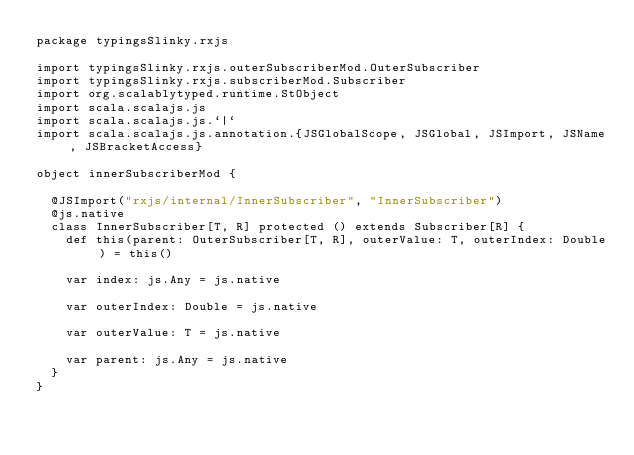Convert code to text. <code><loc_0><loc_0><loc_500><loc_500><_Scala_>package typingsSlinky.rxjs

import typingsSlinky.rxjs.outerSubscriberMod.OuterSubscriber
import typingsSlinky.rxjs.subscriberMod.Subscriber
import org.scalablytyped.runtime.StObject
import scala.scalajs.js
import scala.scalajs.js.`|`
import scala.scalajs.js.annotation.{JSGlobalScope, JSGlobal, JSImport, JSName, JSBracketAccess}

object innerSubscriberMod {
  
  @JSImport("rxjs/internal/InnerSubscriber", "InnerSubscriber")
  @js.native
  class InnerSubscriber[T, R] protected () extends Subscriber[R] {
    def this(parent: OuterSubscriber[T, R], outerValue: T, outerIndex: Double) = this()
    
    var index: js.Any = js.native
    
    var outerIndex: Double = js.native
    
    var outerValue: T = js.native
    
    var parent: js.Any = js.native
  }
}
</code> 